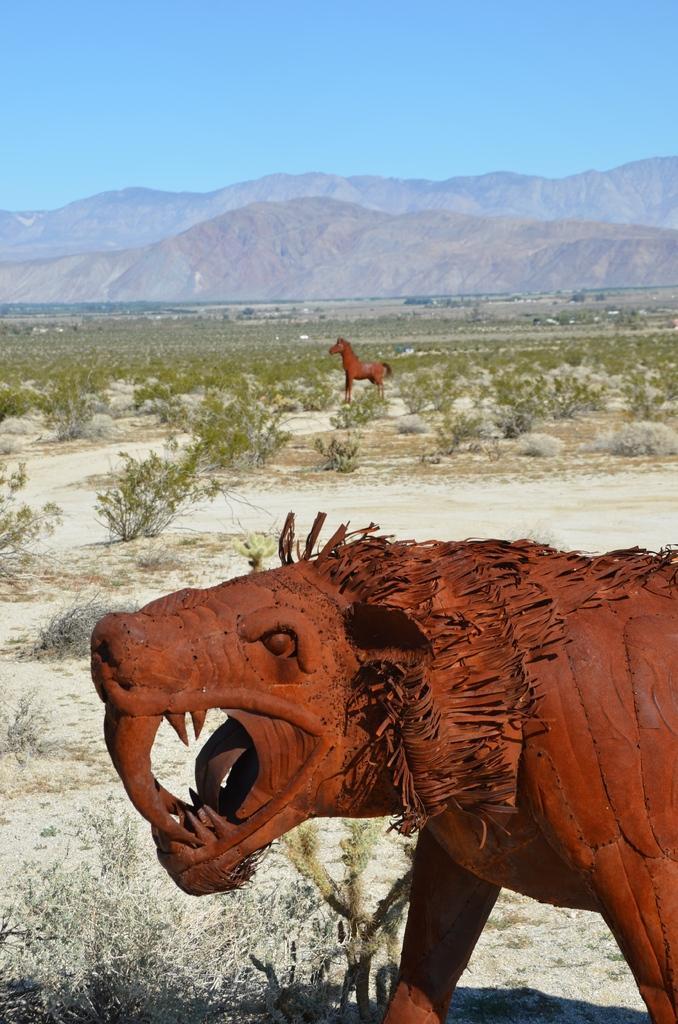Could you give a brief overview of what you see in this image? In this picture I can see statues of two animals, and there are plants, trees, hills, and in the background there is sky. 